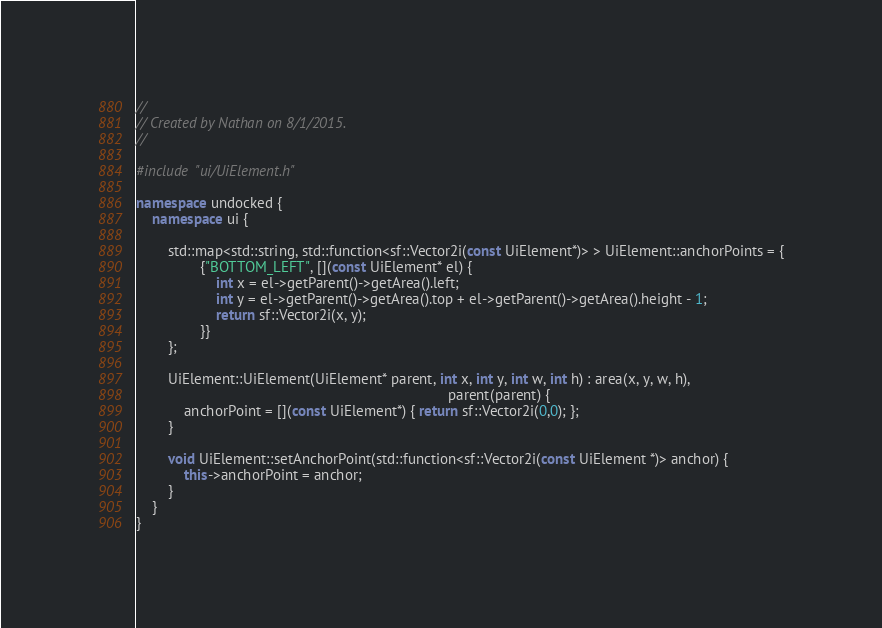<code> <loc_0><loc_0><loc_500><loc_500><_C++_>//
// Created by Nathan on 8/1/2015.
//

#include "ui/UiElement.h"

namespace undocked {
    namespace ui {

        std::map<std::string, std::function<sf::Vector2i(const UiElement*)> > UiElement::anchorPoints = {
                {"BOTTOM_LEFT", [](const UiElement* el) {
                    int x = el->getParent()->getArea().left;
                    int y = el->getParent()->getArea().top + el->getParent()->getArea().height - 1;
                    return sf::Vector2i(x, y);
                }}
        };

        UiElement::UiElement(UiElement* parent, int x, int y, int w, int h) : area(x, y, w, h),
                                                                              parent(parent) {
            anchorPoint = [](const UiElement*) { return sf::Vector2i(0,0); };
        }

        void UiElement::setAnchorPoint(std::function<sf::Vector2i(const UiElement *)> anchor) {
            this->anchorPoint = anchor;
        }
    }
}
</code> 